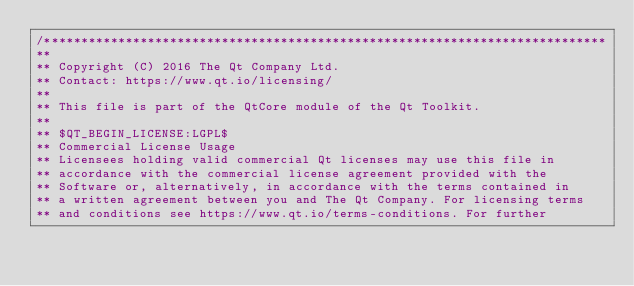<code> <loc_0><loc_0><loc_500><loc_500><_ObjectiveC_>/****************************************************************************
**
** Copyright (C) 2016 The Qt Company Ltd.
** Contact: https://www.qt.io/licensing/
**
** This file is part of the QtCore module of the Qt Toolkit.
**
** $QT_BEGIN_LICENSE:LGPL$
** Commercial License Usage
** Licensees holding valid commercial Qt licenses may use this file in
** accordance with the commercial license agreement provided with the
** Software or, alternatively, in accordance with the terms contained in
** a written agreement between you and The Qt Company. For licensing terms
** and conditions see https://www.qt.io/terms-conditions. For further</code> 